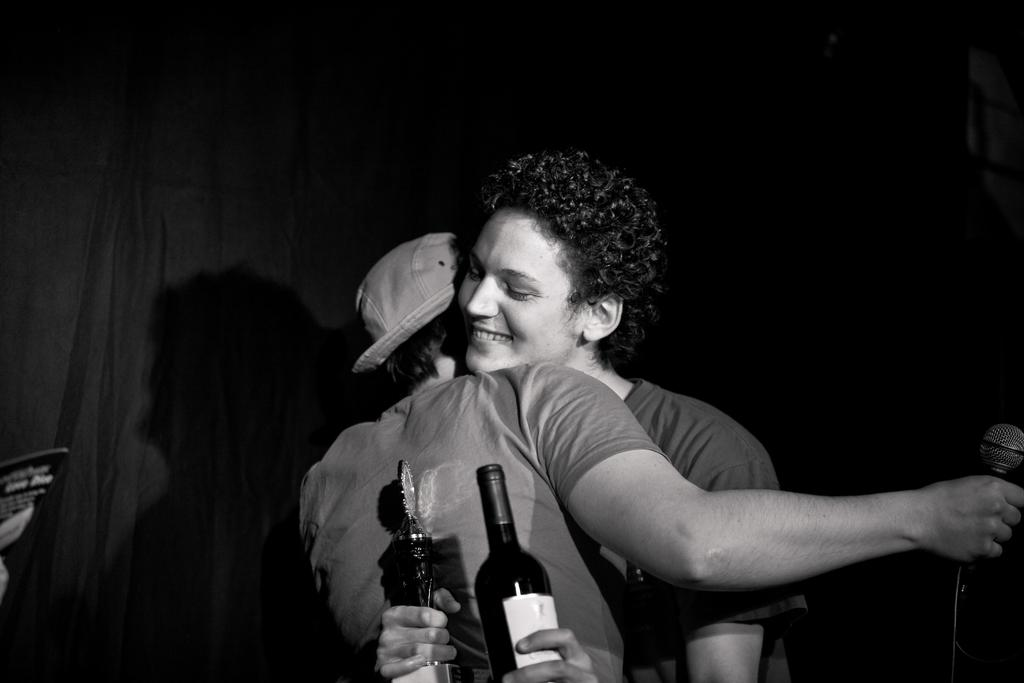What is present in the image that can be used for covering or blocking light? There is a curtain in the image. How many people are in the image? There are two people in the image. What is one of the people holding? One of the people is holding a microphone. What is the other person holding? The other person is holding bottles. Are the two people in the image sisters? There is no information provided about the relationship between the two people in the image. --- Facts: 1. There is a car in the image. 2. The car is red. 3. The car has four wheels. 4. The car has a license plate. 5. The car is parked on the street. Absurd Topics: parrot, dance, mountain Conversation: What is the main subject of the image? The main subject of the image is a car. What color is the car? The car is red. How many wheels does the car have? The car has four wheels. Does the car have any identifying features? Yes, the car has a license plate. Where is the car located in the image? The car is parked on the street. Reasoning: Let's think step by step in order to produce the conversation. We start by identifying the main subject in the image, which is the car. Then, we expand the conversation to include other details about the car, such as its color, number of wheels, and the presence of a license plate. Finally, we describe the car's location in the image, which is parked on the street. Each question is designed to elicit a specific detail about the image that is known from the provided facts. Absurd Question/Answer: Can you see a parrot dancing on top of the mountain in the image? There is no parrot, dancing, or mountain present in the image. 